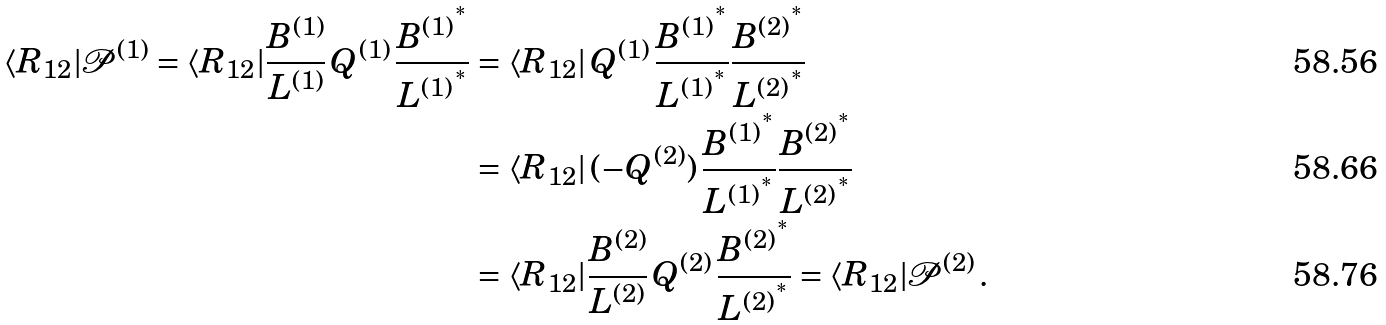Convert formula to latex. <formula><loc_0><loc_0><loc_500><loc_500>\langle { R _ { 1 2 } } | \mathcal { P } ^ { ( 1 ) } = \langle R _ { 1 2 } | \frac { B ^ { ( 1 ) } } { L ^ { ( 1 ) } } \, Q ^ { ( 1 ) } \, \frac { { B ^ { ( 1 ) } } ^ { ^ { * } } } { { L ^ { ( 1 ) } } ^ { ^ { * } } } & = \langle R _ { 1 2 } | \, Q ^ { ( 1 ) } \, \frac { { B ^ { ( 1 ) } } ^ { ^ { * } } } { { L ^ { ( 1 ) } } ^ { ^ { * } } } \frac { { B ^ { ( 2 ) } } ^ { ^ { * } } } { { L ^ { ( 2 ) } } ^ { ^ { * } } } \\ & = \langle R _ { 1 2 } | \, ( - Q ^ { ( 2 ) } ) \, \frac { { B ^ { ( 1 ) } } ^ { ^ { * } } } { { L ^ { ( 1 ) } } ^ { ^ { * } } } \frac { { B ^ { ( 2 ) } } ^ { ^ { * } } } { { L ^ { ( 2 ) } } ^ { ^ { * } } } \\ & = \langle R _ { 1 2 } | \frac { { B ^ { ( 2 ) } } } { { L ^ { ( 2 ) } } } \, Q ^ { ( 2 ) } \, \frac { { B ^ { ( 2 ) } } ^ { ^ { * } } } { { L ^ { ( 2 ) } } ^ { ^ { * } } } = \langle { R _ { 1 2 } } | \mathcal { P } ^ { ( 2 ) } \, .</formula> 